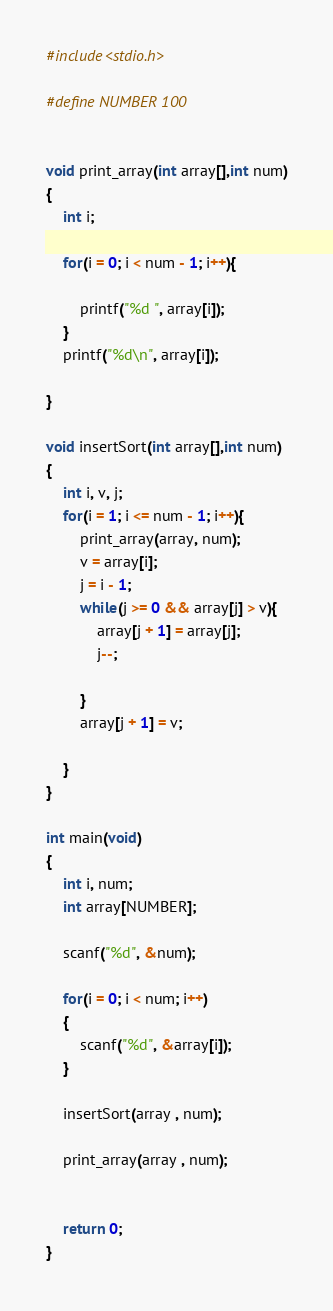Convert code to text. <code><loc_0><loc_0><loc_500><loc_500><_C_>#include<stdio.h>

#define NUMBER 100


void print_array(int array[],int num)
{
	int i;
	
	for(i = 0; i < num - 1; i++){
		
		printf("%d ", array[i]);
	}
	printf("%d\n", array[i]);
	
}
	
void insertSort(int array[],int num)
{
	int i, v, j;
	for(i = 1; i <= num - 1; i++){
		print_array(array, num);
		v = array[i];
		j = i - 1;
		while(j >= 0 && array[j] > v){
			array[j + 1] = array[j];
			j--;
			
		}
		array[j + 1] = v;
	
    }
}

int main(void)
{
	int i, num;
	int array[NUMBER];

	scanf("%d", &num);
	
	for(i = 0; i < num; i++)
	{
		scanf("%d", &array[i]);
	}
	
	insertSort(array , num);
	
	print_array(array , num);
	
	
	return 0;
}
</code> 